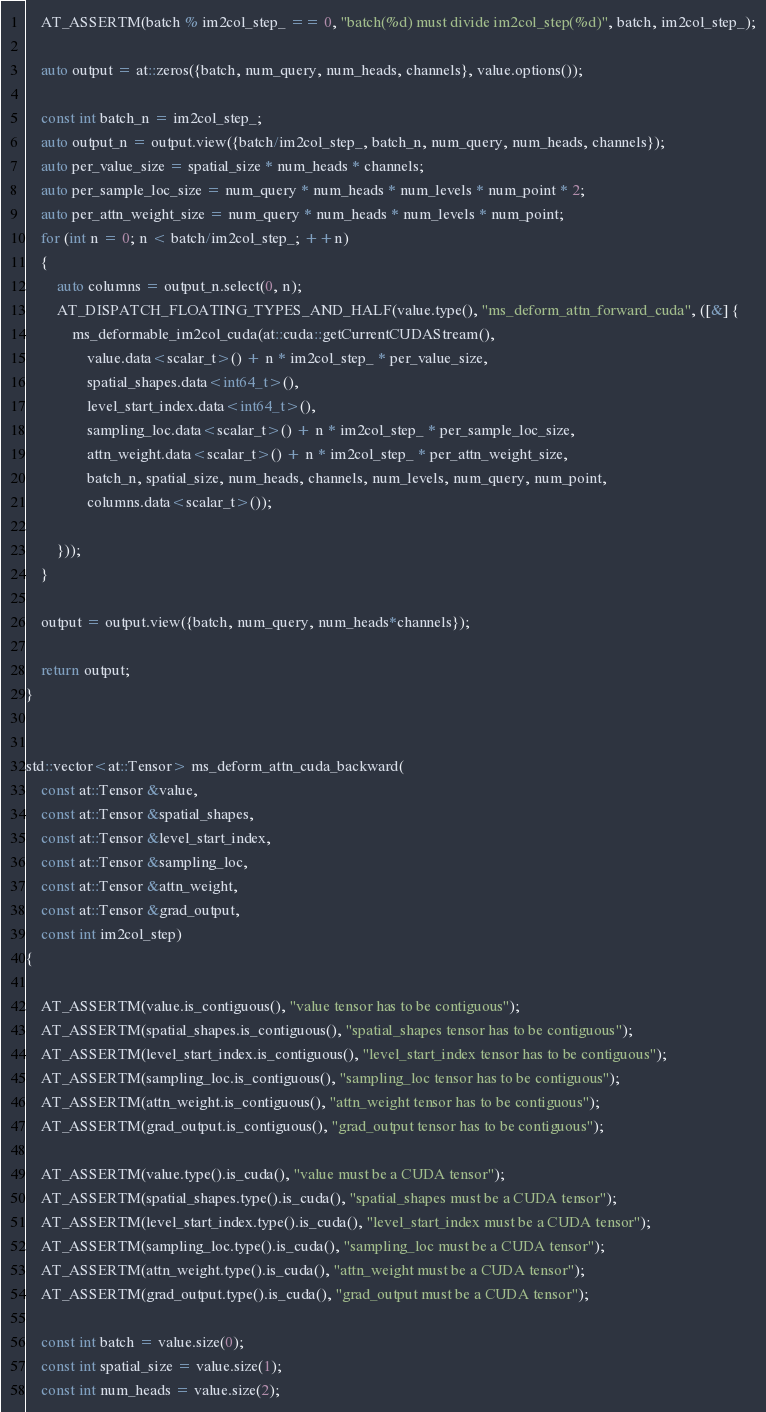<code> <loc_0><loc_0><loc_500><loc_500><_Cuda_>
    AT_ASSERTM(batch % im2col_step_ == 0, "batch(%d) must divide im2col_step(%d)", batch, im2col_step_);
    
    auto output = at::zeros({batch, num_query, num_heads, channels}, value.options());

    const int batch_n = im2col_step_;
    auto output_n = output.view({batch/im2col_step_, batch_n, num_query, num_heads, channels});
    auto per_value_size = spatial_size * num_heads * channels;
    auto per_sample_loc_size = num_query * num_heads * num_levels * num_point * 2;
    auto per_attn_weight_size = num_query * num_heads * num_levels * num_point;
    for (int n = 0; n < batch/im2col_step_; ++n)
    {
        auto columns = output_n.select(0, n);
        AT_DISPATCH_FLOATING_TYPES_AND_HALF(value.type(), "ms_deform_attn_forward_cuda", ([&] {
            ms_deformable_im2col_cuda(at::cuda::getCurrentCUDAStream(),
                value.data<scalar_t>() + n * im2col_step_ * per_value_size,
                spatial_shapes.data<int64_t>(),
                level_start_index.data<int64_t>(),
                sampling_loc.data<scalar_t>() + n * im2col_step_ * per_sample_loc_size,
                attn_weight.data<scalar_t>() + n * im2col_step_ * per_attn_weight_size,
                batch_n, spatial_size, num_heads, channels, num_levels, num_query, num_point,
                columns.data<scalar_t>());

        }));
    }

    output = output.view({batch, num_query, num_heads*channels});

    return output;
}


std::vector<at::Tensor> ms_deform_attn_cuda_backward(
    const at::Tensor &value,
    const at::Tensor &spatial_shapes,
    const at::Tensor &level_start_index,
    const at::Tensor &sampling_loc,
    const at::Tensor &attn_weight,
    const at::Tensor &grad_output,
    const int im2col_step)
{

    AT_ASSERTM(value.is_contiguous(), "value tensor has to be contiguous");
    AT_ASSERTM(spatial_shapes.is_contiguous(), "spatial_shapes tensor has to be contiguous");
    AT_ASSERTM(level_start_index.is_contiguous(), "level_start_index tensor has to be contiguous");
    AT_ASSERTM(sampling_loc.is_contiguous(), "sampling_loc tensor has to be contiguous");
    AT_ASSERTM(attn_weight.is_contiguous(), "attn_weight tensor has to be contiguous");
    AT_ASSERTM(grad_output.is_contiguous(), "grad_output tensor has to be contiguous");

    AT_ASSERTM(value.type().is_cuda(), "value must be a CUDA tensor");
    AT_ASSERTM(spatial_shapes.type().is_cuda(), "spatial_shapes must be a CUDA tensor");
    AT_ASSERTM(level_start_index.type().is_cuda(), "level_start_index must be a CUDA tensor");
    AT_ASSERTM(sampling_loc.type().is_cuda(), "sampling_loc must be a CUDA tensor");
    AT_ASSERTM(attn_weight.type().is_cuda(), "attn_weight must be a CUDA tensor");
    AT_ASSERTM(grad_output.type().is_cuda(), "grad_output must be a CUDA tensor");

    const int batch = value.size(0);
    const int spatial_size = value.size(1);
    const int num_heads = value.size(2);</code> 